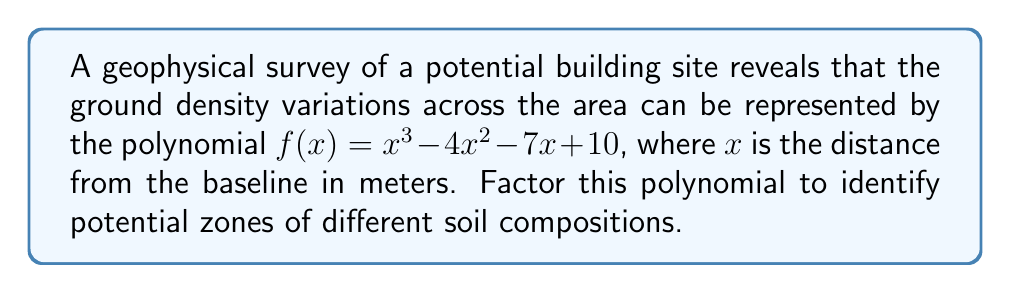Show me your answer to this math problem. To factor this polynomial, we'll follow these steps:

1) First, check if there are any rational roots using the rational root theorem. The possible rational roots are the factors of the constant term: ±1, ±2, ±5, ±10.

2) Using synthetic division or direct substitution, we find that 5 is a root of the polynomial.

3) Divide the polynomial by $(x-5)$:

   $f(x) = (x-5)(x^2 + x - 2)$

4) Now we need to factor the quadratic term $x^2 + x - 2$. We can do this by finding two numbers that multiply to give -2 and add to give 1.

5) These numbers are 2 and -1.

6) Therefore, we can factor $x^2 + x - 2$ as $(x+2)(x-1)$.

7) Combining all factors, we get:

   $f(x) = (x-5)(x+2)(x-1)$

This factorization represents three linear terms, each corresponding to a potential boundary between different soil composition zones at 5 meters, -2 meters, and 1 meter from the baseline.
Answer: $(x-5)(x+2)(x-1)$ 